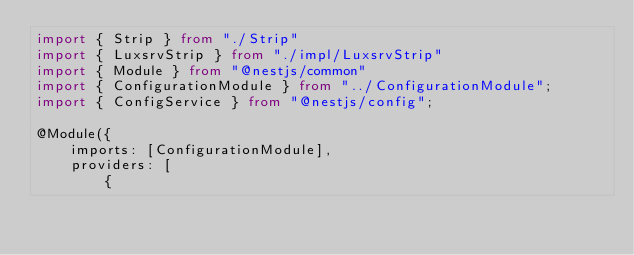<code> <loc_0><loc_0><loc_500><loc_500><_TypeScript_>import { Strip } from "./Strip"
import { LuxsrvStrip } from "./impl/LuxsrvStrip"
import { Module } from "@nestjs/common"
import { ConfigurationModule } from "../ConfigurationModule";
import { ConfigService } from "@nestjs/config";

@Module({
    imports: [ConfigurationModule],
    providers: [
        {</code> 